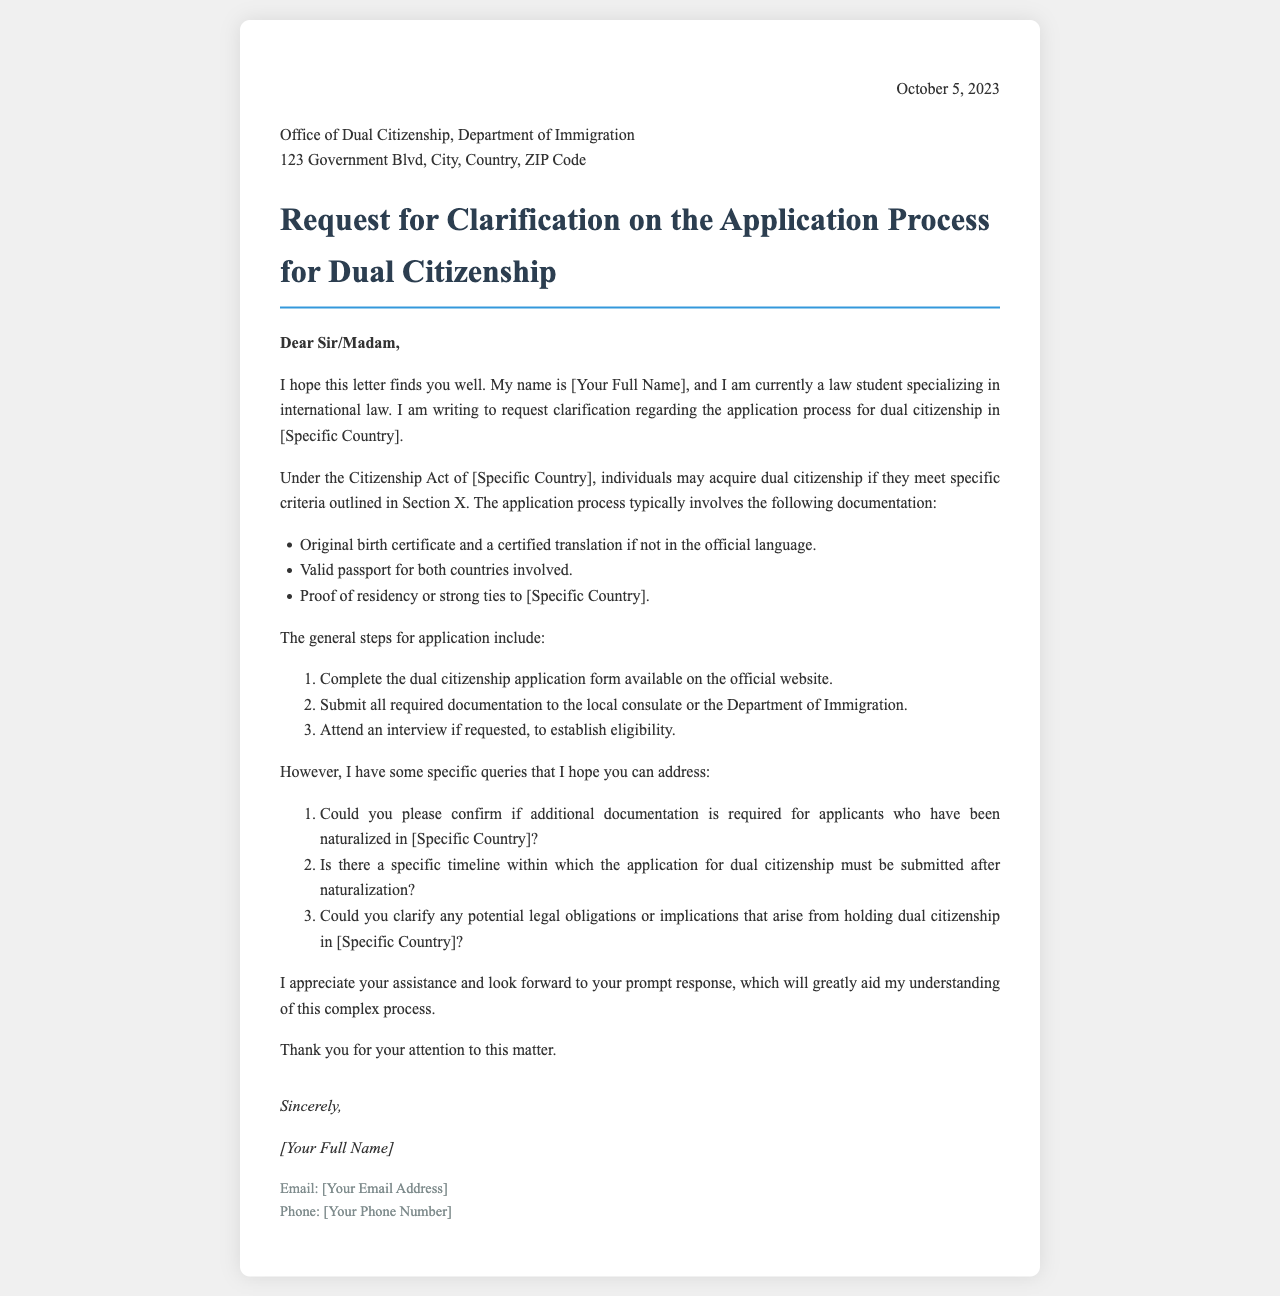What is the date of the letter? The date mentioned at the top of the letter is October 5, 2023.
Answer: October 5, 2023 Who is the letter addressed to? The letter is addressed to the Office of Dual Citizenship, Department of Immigration.
Answer: Office of Dual Citizenship, Department of Immigration What is the main request in the letter? The main request is for clarification on the application process for dual citizenship in a specific country.
Answer: Clarification on the application process for dual citizenship Which document is required in a certified translation if not in the official language? The original birth certificate requires a certified translation if it is not in the official language.
Answer: Original birth certificate What are the first two steps of the application process? The first two steps involve completing the dual citizenship application form and submitting all required documentation.
Answer: Complete the dual citizenship application form; Submit all required documentation What is one specific query the writer asks regarding naturalization? The writer asks if additional documentation is required for applicants who have been naturalized.
Answer: Additional documentation for naturalized applicants What potential legal aspect does the writer inquire about? The writer inquires about potential legal obligations or implications of holding dual citizenship.
Answer: Legal obligations or implications of dual citizenship What is the tone of the letter? The tone of the letter is formal and respectful.
Answer: Formal and respectful 